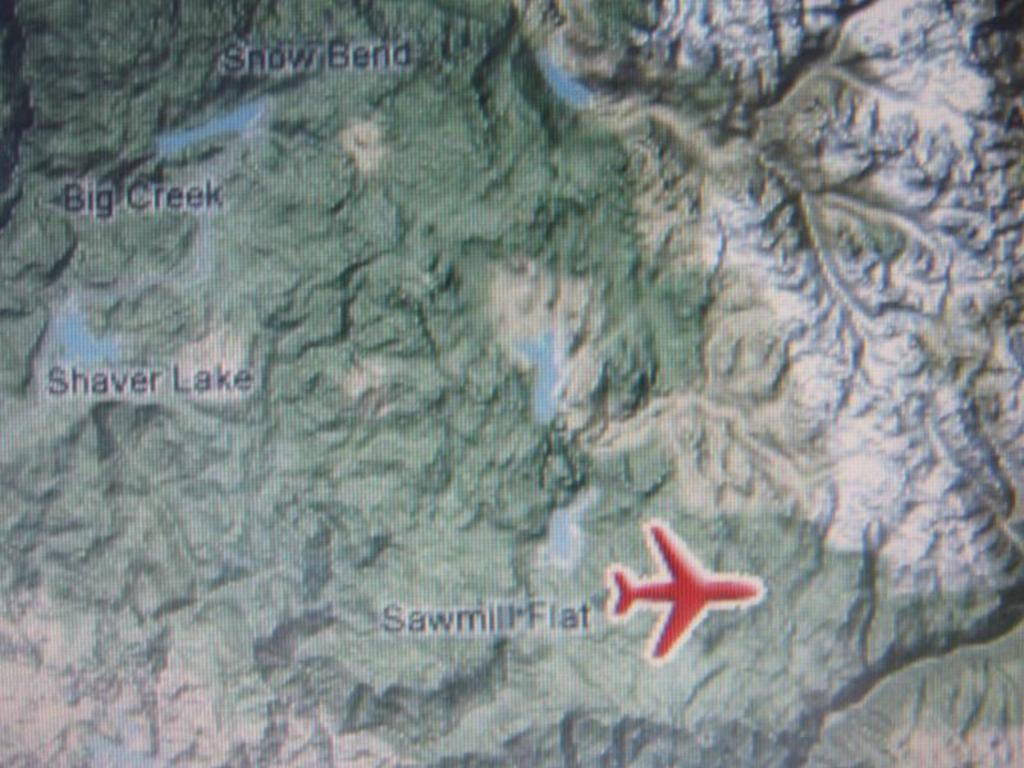What is the main subject of the image? The main subject of the image is a map. What is the color of the writing on the map? The writing on the map is in black color. What other element is present on the map? There is a design of an airplane on the map. What type of verse can be seen written on the tank in the image? There is no tank present in the image, and therefore no verse can be seen written on it. 